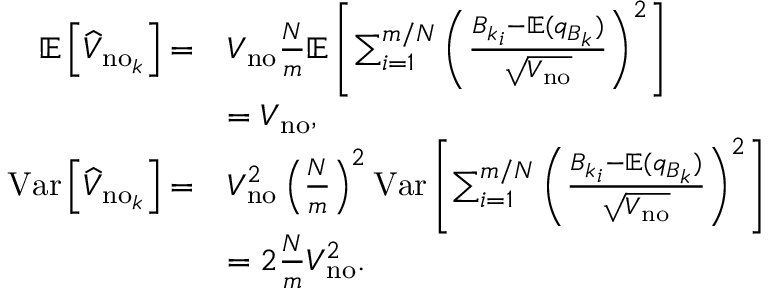Convert formula to latex. <formula><loc_0><loc_0><loc_500><loc_500>\begin{array} { r l } { \mathbb { E } \left [ \widehat { V } _ { n o _ { k } } \right ] = } & { V _ { n o } \frac { N } { m } \mathbb { E } \left [ \sum _ { i = 1 } ^ { m / N } \left ( \frac { { B _ { k } } _ { i } - \mathbb { E } ( q _ { B _ { k } } ) } { \sqrt { V _ { n o } } } \right ) ^ { 2 } \right ] } \\ & { = V _ { n o } , } \\ { V a r \left [ \widehat { V } _ { n o _ { k } } \right ] = } & { V _ { n o } ^ { 2 } \left ( \frac { N } { m } \right ) ^ { 2 } V a r \left [ \sum _ { i = 1 } ^ { m / N } \left ( \frac { { B _ { k } } _ { i } - \mathbb { E } ( q _ { B _ { k } } ) } { \sqrt { V _ { n o } } } \right ) ^ { 2 } \right ] } \\ & { = 2 \frac { N } { m } V _ { n o } ^ { 2 } . } \end{array}</formula> 